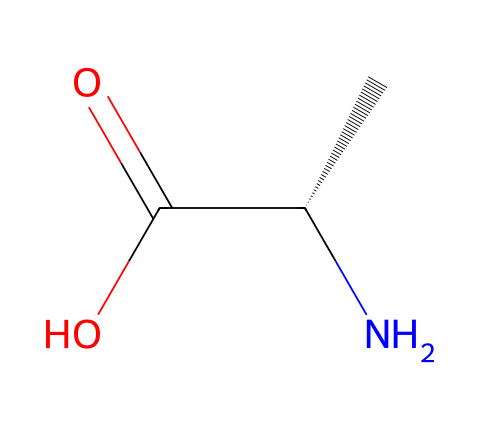How many chiral centers are present in this compound? The compound contains one chiral center, indicated by the presence of a carbon atom connected to four different substituents, specifically the amino group (NH2), carboxylic acid group (COOH), hydrogen atom (H), and a side chain (C).
Answer: one What is the significance of the chiral center in amino acids? The chiral center allows amino acids to exist in two enantiomeric forms, which can have different biological roles; only one enantiomer is typically biologically active.
Answer: enantiomers What is the functional group present in this molecule? The molecule features a carboxylic acid group (COOH) and an amino group (NH2), identifying it as an amino acid.
Answer: amino acid What type of bond exists between the carbon atom and the carboxylic acid group? The bond is a double bond between the carbon atom (C) of the chiral center and the oxygen of the carboxylic acid (C=O), indicating a carbonyl functional group.
Answer: double bond How does the chiral nature of this amino acid affect protein structure? The chiral nature affects the spatial arrangement of amino acids in proteins, influencing the folding and shape of the protein, which is crucial for its function.
Answer: spatial arrangement Which enantiomer is commonly found in proteins? The L-form of amino acids is the enantiomer that is predominantly found in proteins, making it significant for biological systems.
Answer: L-form 